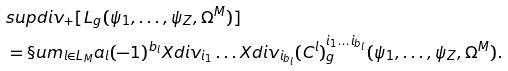Convert formula to latex. <formula><loc_0><loc_0><loc_500><loc_500>& s u p d i v _ { + } [ L _ { g } ( \psi _ { 1 } , \dots , \psi _ { Z } , \Omega ^ { M } ) ] \\ & = \S u m _ { l \in L _ { M } } a _ { l } ( - 1 ) ^ { b _ { l } } X d i v _ { i _ { 1 } } \dots X d i v _ { i _ { b _ { l } } } ( C ^ { l } ) ^ { i _ { 1 } \dots i _ { b _ { l } } } _ { g } ( \psi _ { 1 } , \dots , \psi _ { Z } , \Omega ^ { M } ) .</formula> 